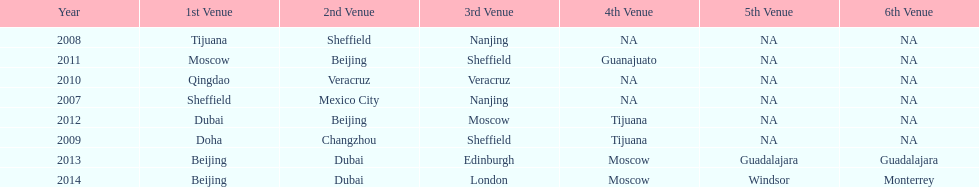In what year was the 3rd venue the same as 2011's 1st venue? 2012. 